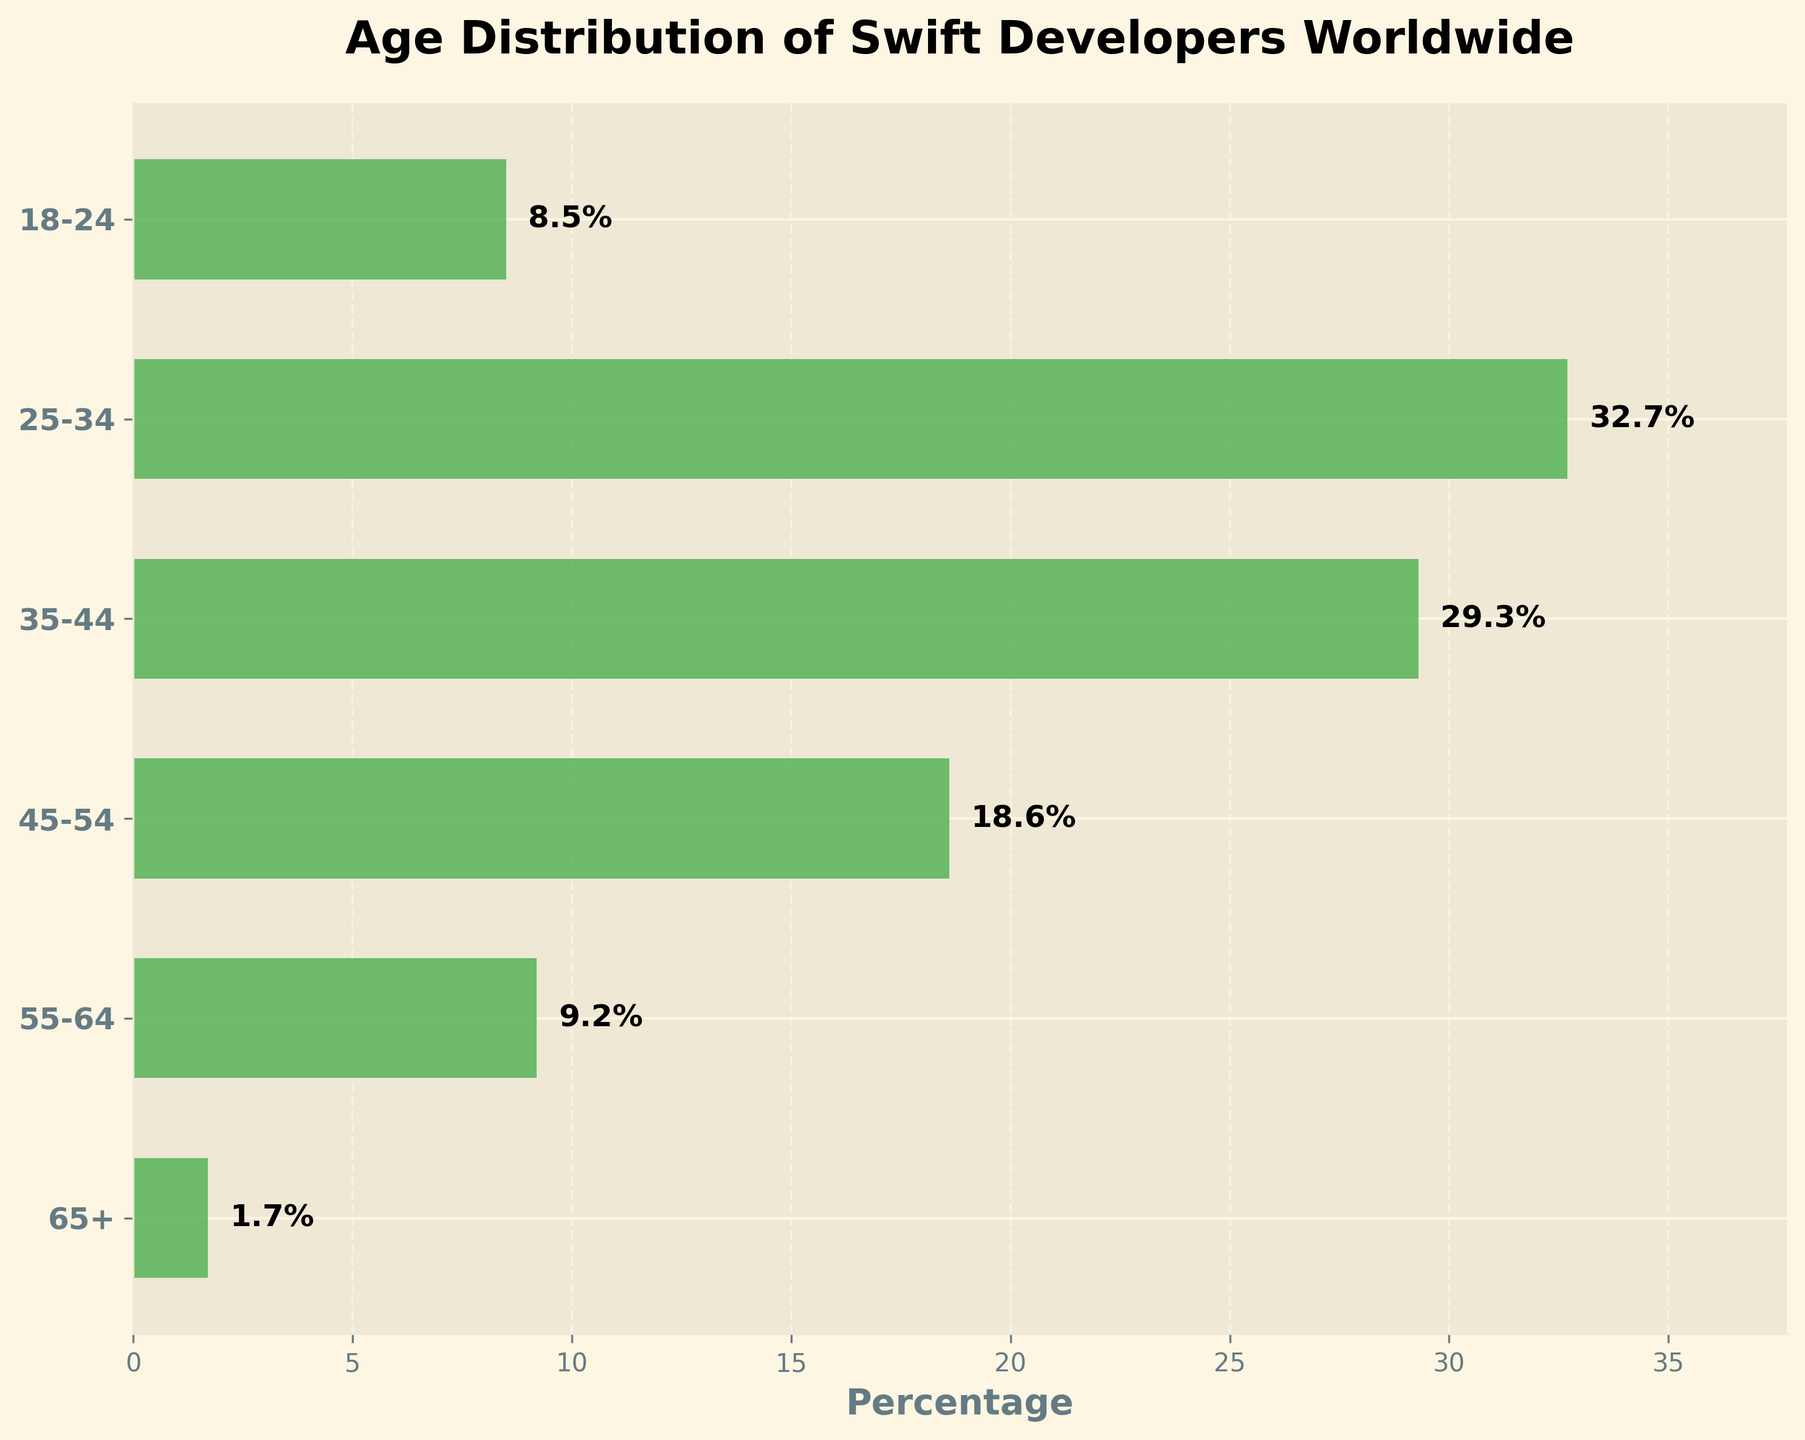What's the title of the figure? The title is usually displayed at the top of the figure. It is prominently centered and formatted in a bold, larger font size.
Answer: Age Distribution of Swift Developers Worldwide What age group has the highest percentage of Swift developers? The percentages for each age group are represented by horizontal bars. The longest bar will indicate the highest percentage.
Answer: 25-34 How many age groups are represented in the figure? The age groups are listed along the vertical axis. Count the number of different labels to determine the number of age groups.
Answer: 6 Which age group has the lowest percentage of Swift developers? The shortest bar in the figure represents the lowest percentage.
Answer: 65+ What is the combined percentage of Swift developers aged 35-54? To get the combined percentage, add the percentages of the 35-44 and 45-54 age groups. 35-44 has 29.3% and 45-54 has 18.6%. 29.3 + 18.6 = 47.9%
Answer: 47.9% By how much does the percentage of developers aged 25-34 exceed those aged 18-24? Subtract the percentage of the 18-24 age group from the 25-34 age group. 32.7% - 8.5% = 24.2%
Answer: 24.2% Which age group represents the middle (median) percentage of Swift developers? With an even number of age groups (6), the median would be the average of the 3rd and 4th largest percentages. In order: 1.7%, 8.5%, 9.2%, 18.6%, 29.3%, 32.7%. Middle values are 9.2% (55-64) and 18.6% (45-54). Average: (9.2 + 18.6) / 2 = 13.9%.
Answer: Ages 55-64 and 45-54 How does the percentage of developers aged 55-64 compare to those aged 65+? Compare the lengths of their horizontal bars. The percentage for 55-64 is higher than that of 65+ by 9.2% - 1.7% = 7.5%.
Answer: 7.5% higher What is the total percentage of Swift developers aged 45 and above? Add the percentages of the age groups 45-54, 55-64, and 65+. 18.6% + 9.2% + 1.7% = 29.5%.
Answer: 29.5% What can be inferred about the distribution of Swift developers across different age groups? The longest bars with higher percentages are in the age groups 25-34 and 35-44, indicating a higher concentration of Swift developers in these age ranges compared to other age groups.
Answer: Majority in 25-34 and 35-44 